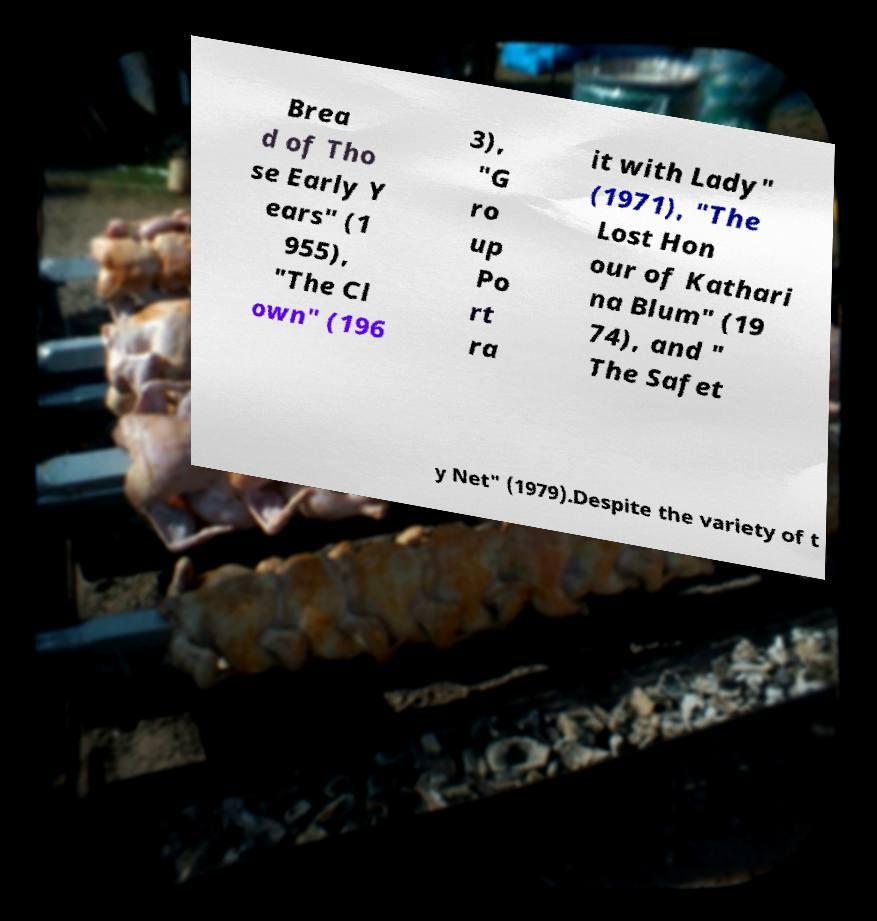Could you extract and type out the text from this image? Brea d of Tho se Early Y ears" (1 955), "The Cl own" (196 3), "G ro up Po rt ra it with Lady" (1971), "The Lost Hon our of Kathari na Blum" (19 74), and " The Safet y Net" (1979).Despite the variety of t 